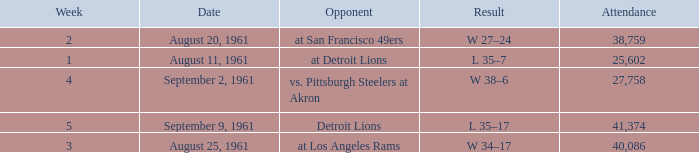What was the score of the Browns week 4 game? W 38–6. 